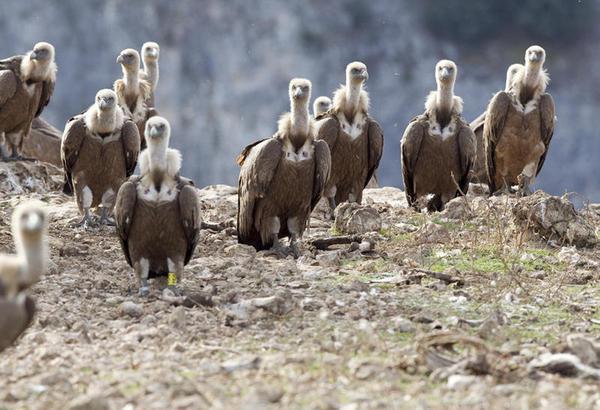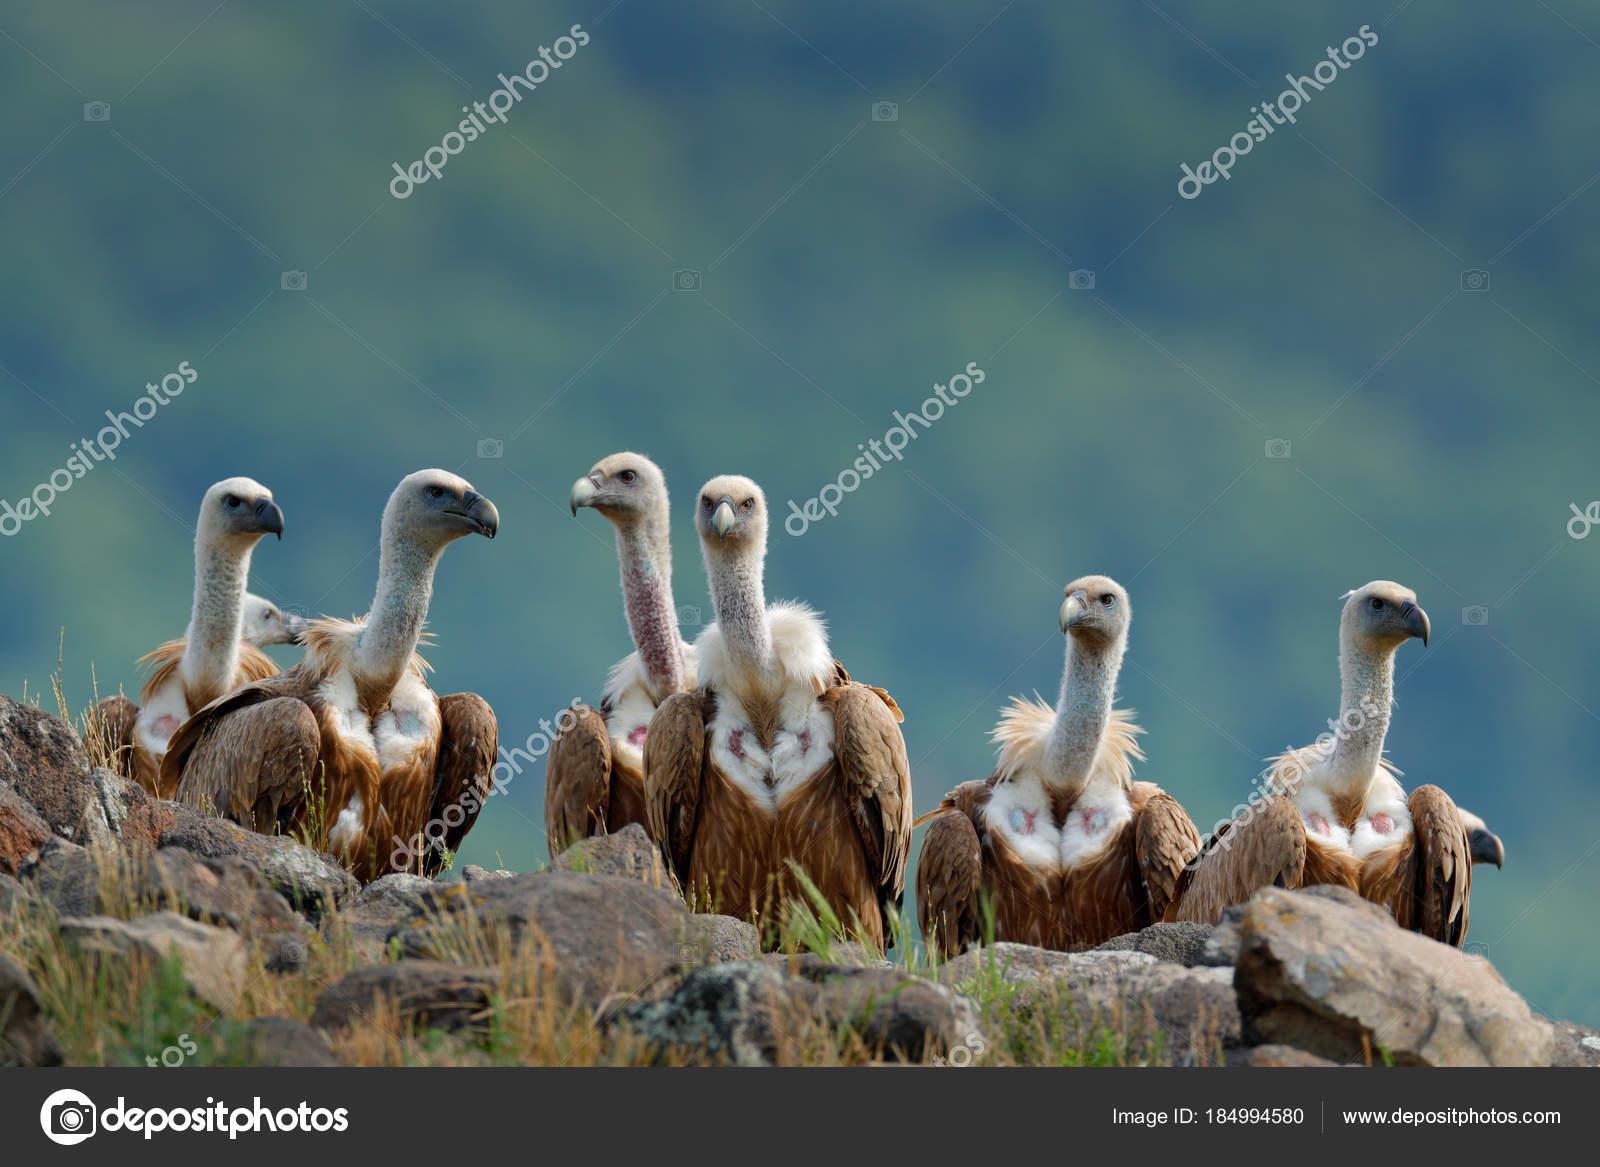The first image is the image on the left, the second image is the image on the right. Given the left and right images, does the statement "In at least one image there are four vultures." hold true? Answer yes or no. No. The first image is the image on the left, the second image is the image on the right. Evaluate the accuracy of this statement regarding the images: "One of the images shows four vultures, while the other shows many more, and none of them are currently eating.". Is it true? Answer yes or no. No. 